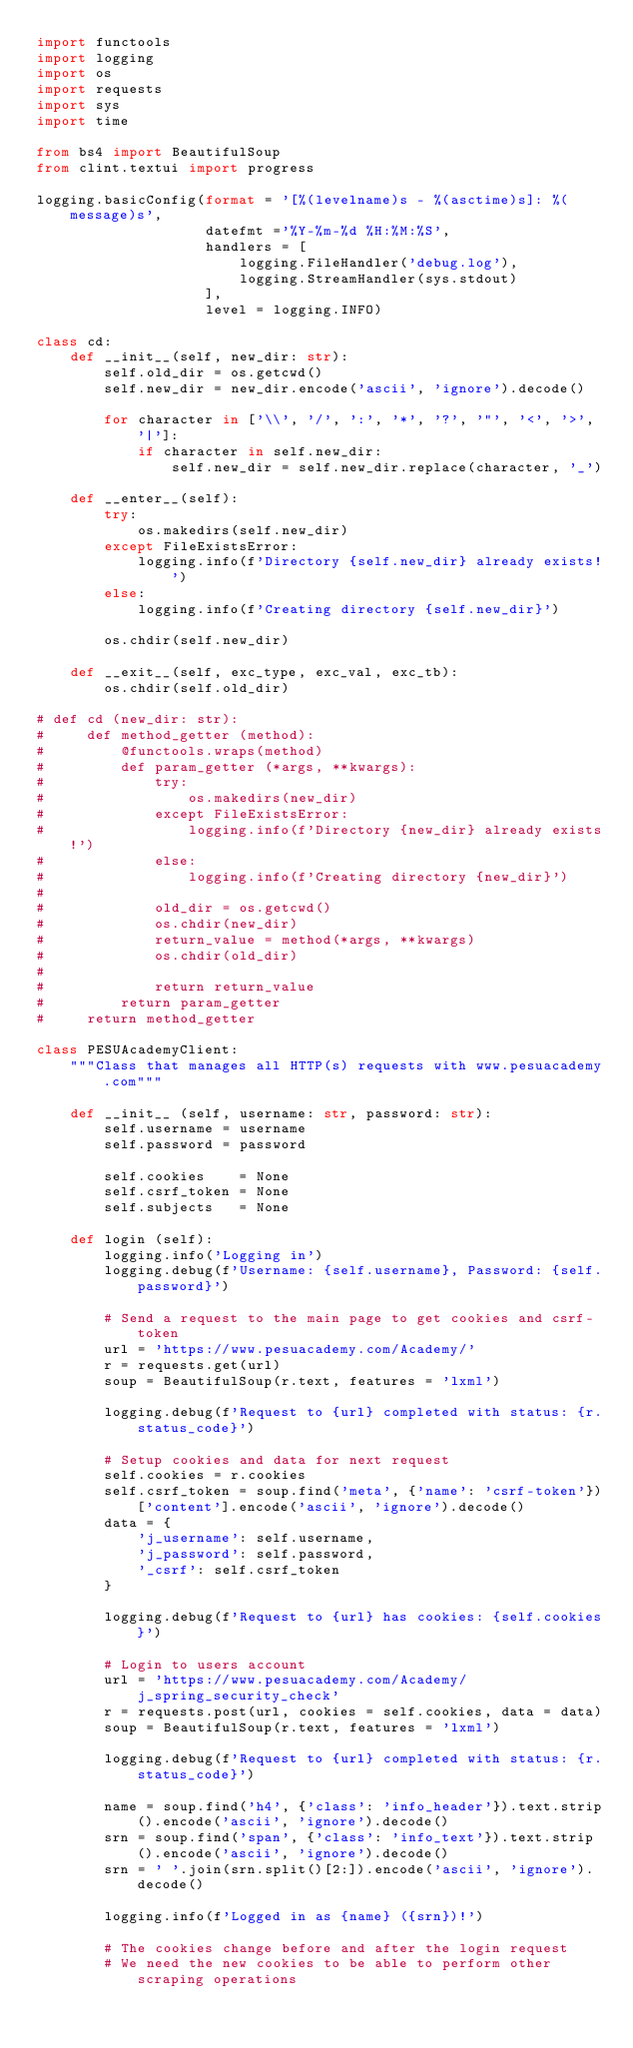<code> <loc_0><loc_0><loc_500><loc_500><_Python_>import functools
import logging
import os
import requests
import sys
import time

from bs4 import BeautifulSoup
from clint.textui import progress

logging.basicConfig(format = '[%(levelname)s - %(asctime)s]: %(message)s',
                    datefmt ='%Y-%m-%d %H:%M:%S',
                    handlers = [
                        logging.FileHandler('debug.log'),
                        logging.StreamHandler(sys.stdout)
                    ],
                    level = logging.INFO)

class cd:
    def __init__(self, new_dir: str):
        self.old_dir = os.getcwd()
        self.new_dir = new_dir.encode('ascii', 'ignore').decode()

        for character in ['\\', '/', ':', '*', '?', '"', '<', '>', '|']:
            if character in self.new_dir:
                self.new_dir = self.new_dir.replace(character, '_')

    def __enter__(self):
        try:
            os.makedirs(self.new_dir)
        except FileExistsError:
            logging.info(f'Directory {self.new_dir} already exists!')
        else:
            logging.info(f'Creating directory {self.new_dir}')

        os.chdir(self.new_dir)

    def __exit__(self, exc_type, exc_val, exc_tb):
        os.chdir(self.old_dir)

# def cd (new_dir: str):
#     def method_getter (method):
#         @functools.wraps(method)
#         def param_getter (*args, **kwargs):
#             try:
#                 os.makedirs(new_dir)
#             except FileExistsError:
#                 logging.info(f'Directory {new_dir} already exists!')
#             else:
#                 logging.info(f'Creating directory {new_dir}')
#
#             old_dir = os.getcwd()
#             os.chdir(new_dir)
#             return_value = method(*args, **kwargs)
#             os.chdir(old_dir)
#
#             return return_value
#         return param_getter
#     return method_getter

class PESUAcademyClient:
    """Class that manages all HTTP(s) requests with www.pesuacademy.com"""

    def __init__ (self, username: str, password: str):
        self.username = username
        self.password = password

        self.cookies    = None
        self.csrf_token = None
        self.subjects   = None

    def login (self):
        logging.info('Logging in')
        logging.debug(f'Username: {self.username}, Password: {self.password}')

        # Send a request to the main page to get cookies and csrf-token
        url = 'https://www.pesuacademy.com/Academy/'
        r = requests.get(url)
        soup = BeautifulSoup(r.text, features = 'lxml')

        logging.debug(f'Request to {url} completed with status: {r.status_code}')

        # Setup cookies and data for next request
        self.cookies = r.cookies
        self.csrf_token = soup.find('meta', {'name': 'csrf-token'})['content'].encode('ascii', 'ignore').decode()
        data = {
            'j_username': self.username,
            'j_password': self.password,
            '_csrf': self.csrf_token
        }

        logging.debug(f'Request to {url} has cookies: {self.cookies}')

        # Login to users account
        url = 'https://www.pesuacademy.com/Academy/j_spring_security_check'
        r = requests.post(url, cookies = self.cookies, data = data)
        soup = BeautifulSoup(r.text, features = 'lxml')

        logging.debug(f'Request to {url} completed with status: {r.status_code}')

        name = soup.find('h4', {'class': 'info_header'}).text.strip().encode('ascii', 'ignore').decode()
        srn = soup.find('span', {'class': 'info_text'}).text.strip().encode('ascii', 'ignore').decode()
        srn = ' '.join(srn.split()[2:]).encode('ascii', 'ignore').decode()

        logging.info(f'Logged in as {name} ({srn})!')

        # The cookies change before and after the login request
        # We need the new cookies to be able to perform other scraping operations</code> 